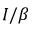Convert formula to latex. <formula><loc_0><loc_0><loc_500><loc_500>I / \beta</formula> 